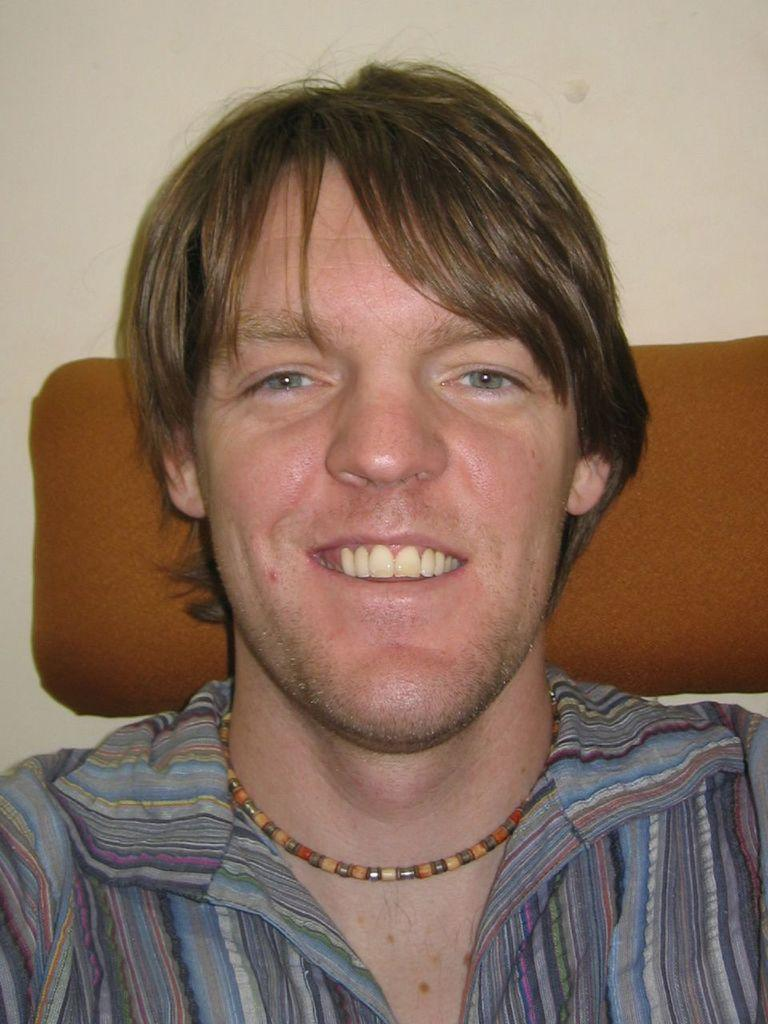Who is present in the image? There is a man in the image. What is the man doing in the image? The man is sitting on a chair. What is the man's facial expression in the image? The man is smiling. What can be seen in the background of the image? There is a wall in the background of the image. How many stars can be seen on the man's tooth in the image? There are no stars visible on the man's tooth in the image. What is the man doing with his thumb in the image? There is no mention of the man's thumb in the image, so it cannot be determined what he is doing with it. 